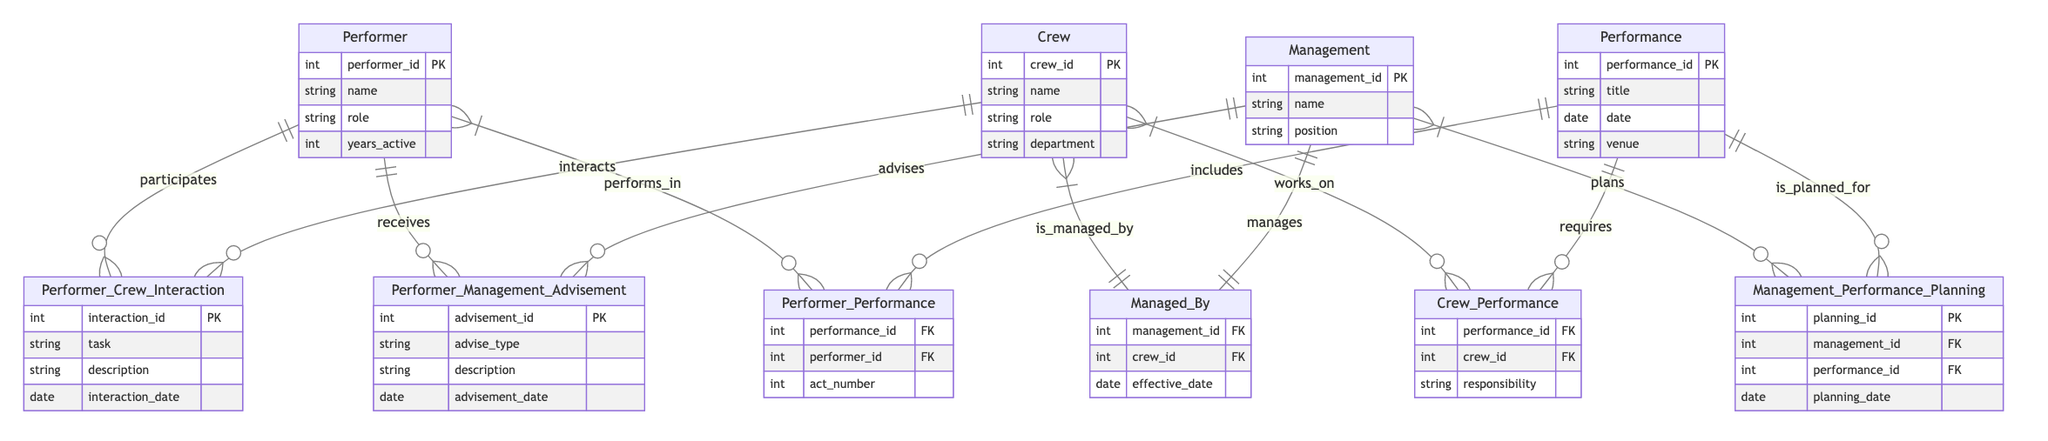What are the entities in the diagram? The diagram includes the following entities: Performer, Crew, Management, and Performance. These can be identified as the main nodes connected by relationships.
Answer: Performer, Crew, Management, Performance How many relationships connect Performer and Crew? There is one relationship that connects Performer and Crew, which is called Performer_Crew_Interaction. This can be determined by counting the lines that connect these two entities in the diagram.
Answer: One What is the role of Management in relation to Performance? Management is involved in performance planning, which is represented by the relationship Management_Performance_Planning that connects the Management and Performance entities. This indicates that Management plays a role in planning performances.
Answer: Plans How many attributes does the Performer entity have? The Performer entity comprises four attributes: performer_id, name, role, and years_active. This is evident from the attributes listed under the Performer entity in the diagram.
Answer: Four What is the nature of the relationship between Crew and Management? The relation between Crew and Management is defined as Managed_By, indicating that Crew is managed by Management. This relationship can be seen as a line connecting the two entities labeled with the relationship name.
Answer: Managed by How many interactions can a Performer have with Crew? A Performer can participate in multiple interactions with Crew, as indicated by the one-to-many relationship denoted by the symbol between Performer and the Performer_Crew_Interaction. This implies that multiple interactions can be recorded for a single Performer.
Answer: Many What is the function of the Performer_Management_Advisement relationship? The Performer_Management_Advisement relationship indicates that Performers receive advisement from Management. It is an interaction that allows Performers to gain guidance or advice on certain matters, illustrated by the directed line in the diagram.
Answer: Advises Which entity is primarily responsible for crew assignments in performances? The Crew entity is responsible for crew assignments in performances, which is demonstrated by the Crew_Performance relationship indicating that Crew works on performances and has defined responsibilities.
Answer: Works on How many entities are directly involved in the Performer_Performance relationship? There are two entities directly involved in the Performer_Performance relationship: Performer and Performance. This is indicated by the relationship line that directly connects these two entities.
Answer: Two 